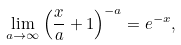Convert formula to latex. <formula><loc_0><loc_0><loc_500><loc_500>\lim _ { a \rightarrow \infty } \left ( \frac { x } { a } + 1 \right ) ^ { - a } = e ^ { - x } ,</formula> 